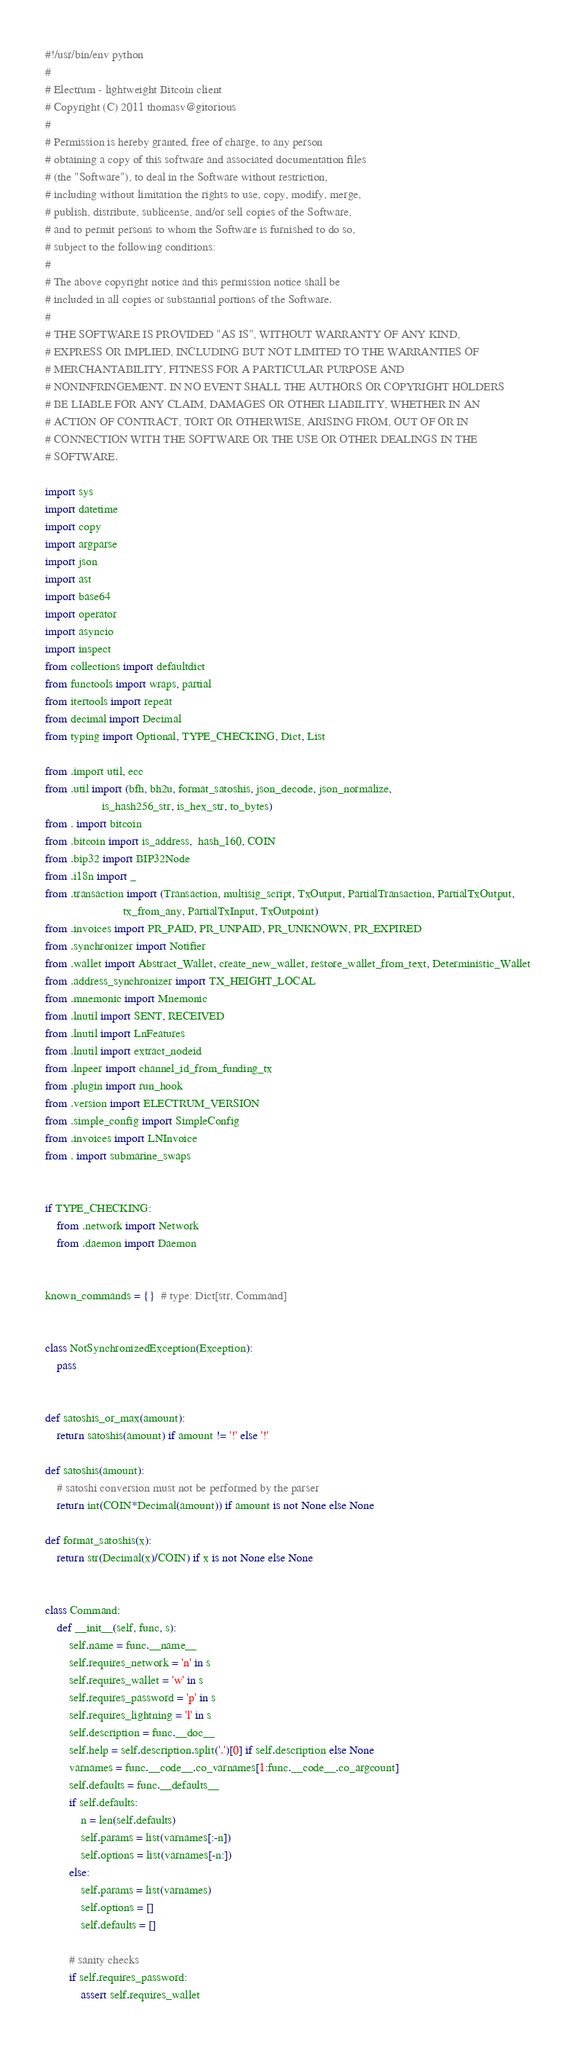<code> <loc_0><loc_0><loc_500><loc_500><_Python_>#!/usr/bin/env python
#
# Electrum - lightweight Bitcoin client
# Copyright (C) 2011 thomasv@gitorious
#
# Permission is hereby granted, free of charge, to any person
# obtaining a copy of this software and associated documentation files
# (the "Software"), to deal in the Software without restriction,
# including without limitation the rights to use, copy, modify, merge,
# publish, distribute, sublicense, and/or sell copies of the Software,
# and to permit persons to whom the Software is furnished to do so,
# subject to the following conditions:
#
# The above copyright notice and this permission notice shall be
# included in all copies or substantial portions of the Software.
#
# THE SOFTWARE IS PROVIDED "AS IS", WITHOUT WARRANTY OF ANY KIND,
# EXPRESS OR IMPLIED, INCLUDING BUT NOT LIMITED TO THE WARRANTIES OF
# MERCHANTABILITY, FITNESS FOR A PARTICULAR PURPOSE AND
# NONINFRINGEMENT. IN NO EVENT SHALL THE AUTHORS OR COPYRIGHT HOLDERS
# BE LIABLE FOR ANY CLAIM, DAMAGES OR OTHER LIABILITY, WHETHER IN AN
# ACTION OF CONTRACT, TORT OR OTHERWISE, ARISING FROM, OUT OF OR IN
# CONNECTION WITH THE SOFTWARE OR THE USE OR OTHER DEALINGS IN THE
# SOFTWARE.

import sys
import datetime
import copy
import argparse
import json
import ast
import base64
import operator
import asyncio
import inspect
from collections import defaultdict
from functools import wraps, partial
from itertools import repeat
from decimal import Decimal
from typing import Optional, TYPE_CHECKING, Dict, List

from .import util, ecc
from .util import (bfh, bh2u, format_satoshis, json_decode, json_normalize,
                   is_hash256_str, is_hex_str, to_bytes)
from . import bitcoin
from .bitcoin import is_address,  hash_160, COIN
from .bip32 import BIP32Node
from .i18n import _
from .transaction import (Transaction, multisig_script, TxOutput, PartialTransaction, PartialTxOutput,
                          tx_from_any, PartialTxInput, TxOutpoint)
from .invoices import PR_PAID, PR_UNPAID, PR_UNKNOWN, PR_EXPIRED
from .synchronizer import Notifier
from .wallet import Abstract_Wallet, create_new_wallet, restore_wallet_from_text, Deterministic_Wallet
from .address_synchronizer import TX_HEIGHT_LOCAL
from .mnemonic import Mnemonic
from .lnutil import SENT, RECEIVED
from .lnutil import LnFeatures
from .lnutil import extract_nodeid
from .lnpeer import channel_id_from_funding_tx
from .plugin import run_hook
from .version import ELECTRUM_VERSION
from .simple_config import SimpleConfig
from .invoices import LNInvoice
from . import submarine_swaps


if TYPE_CHECKING:
    from .network import Network
    from .daemon import Daemon


known_commands = {}  # type: Dict[str, Command]


class NotSynchronizedException(Exception):
    pass


def satoshis_or_max(amount):
    return satoshis(amount) if amount != '!' else '!'

def satoshis(amount):
    # satoshi conversion must not be performed by the parser
    return int(COIN*Decimal(amount)) if amount is not None else None

def format_satoshis(x):
    return str(Decimal(x)/COIN) if x is not None else None


class Command:
    def __init__(self, func, s):
        self.name = func.__name__
        self.requires_network = 'n' in s
        self.requires_wallet = 'w' in s
        self.requires_password = 'p' in s
        self.requires_lightning = 'l' in s
        self.description = func.__doc__
        self.help = self.description.split('.')[0] if self.description else None
        varnames = func.__code__.co_varnames[1:func.__code__.co_argcount]
        self.defaults = func.__defaults__
        if self.defaults:
            n = len(self.defaults)
            self.params = list(varnames[:-n])
            self.options = list(varnames[-n:])
        else:
            self.params = list(varnames)
            self.options = []
            self.defaults = []

        # sanity checks
        if self.requires_password:
            assert self.requires_wallet</code> 